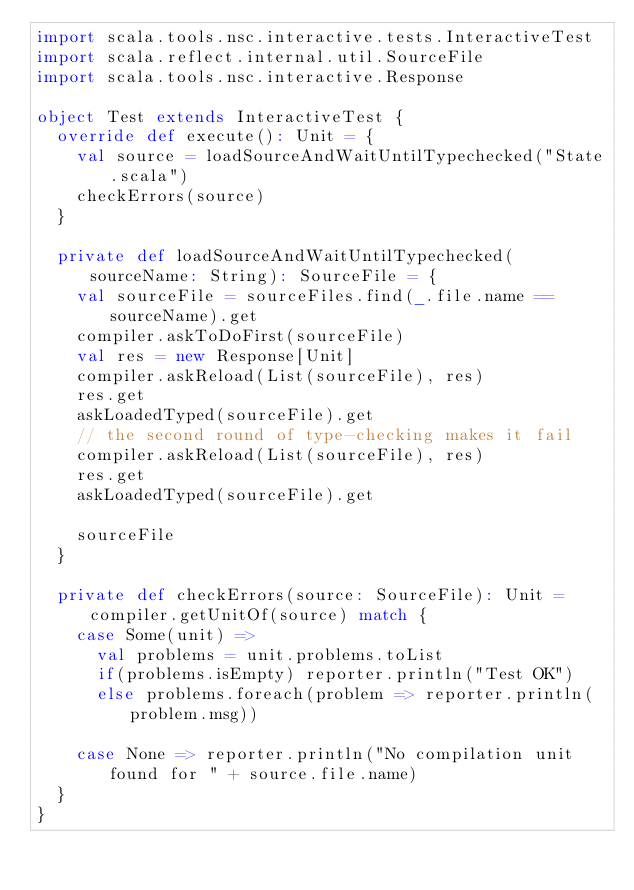<code> <loc_0><loc_0><loc_500><loc_500><_Scala_>import scala.tools.nsc.interactive.tests.InteractiveTest
import scala.reflect.internal.util.SourceFile
import scala.tools.nsc.interactive.Response

object Test extends InteractiveTest {
  override def execute(): Unit = {
    val source = loadSourceAndWaitUntilTypechecked("State.scala")
    checkErrors(source)
  }

  private def loadSourceAndWaitUntilTypechecked(sourceName: String): SourceFile = {
    val sourceFile = sourceFiles.find(_.file.name == sourceName).get
    compiler.askToDoFirst(sourceFile)
    val res = new Response[Unit]
    compiler.askReload(List(sourceFile), res)
    res.get
    askLoadedTyped(sourceFile).get
    // the second round of type-checking makes it fail
    compiler.askReload(List(sourceFile), res)
    res.get
    askLoadedTyped(sourceFile).get

    sourceFile
  }

  private def checkErrors(source: SourceFile): Unit = compiler.getUnitOf(source) match {
    case Some(unit) =>
      val problems = unit.problems.toList
      if(problems.isEmpty) reporter.println("Test OK")
      else problems.foreach(problem => reporter.println(problem.msg))

    case None => reporter.println("No compilation unit found for " + source.file.name)
  }
}
</code> 